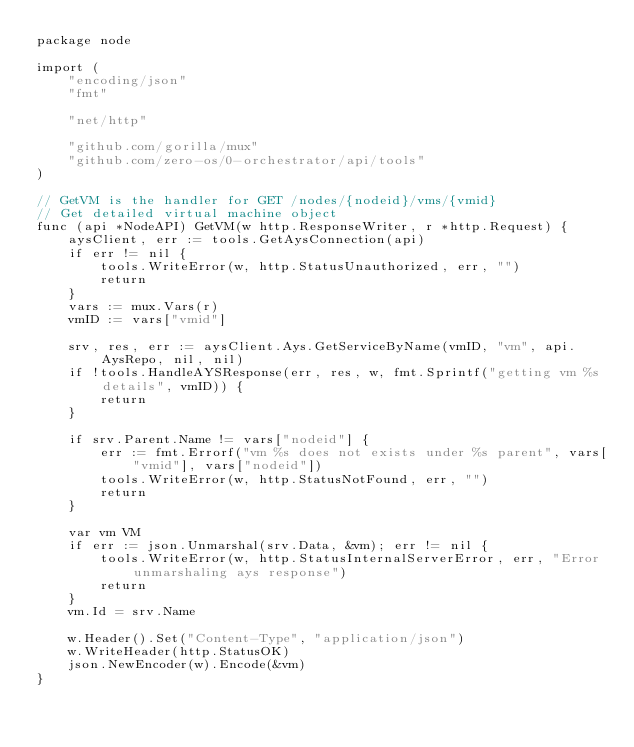Convert code to text. <code><loc_0><loc_0><loc_500><loc_500><_Go_>package node

import (
	"encoding/json"
	"fmt"

	"net/http"

	"github.com/gorilla/mux"
	"github.com/zero-os/0-orchestrator/api/tools"
)

// GetVM is the handler for GET /nodes/{nodeid}/vms/{vmid}
// Get detailed virtual machine object
func (api *NodeAPI) GetVM(w http.ResponseWriter, r *http.Request) {
	aysClient, err := tools.GetAysConnection(api)
	if err != nil {
		tools.WriteError(w, http.StatusUnauthorized, err, "")
		return
	}
	vars := mux.Vars(r)
	vmID := vars["vmid"]

	srv, res, err := aysClient.Ays.GetServiceByName(vmID, "vm", api.AysRepo, nil, nil)
	if !tools.HandleAYSResponse(err, res, w, fmt.Sprintf("getting vm %s details", vmID)) {
		return
	}

	if srv.Parent.Name != vars["nodeid"] {
		err := fmt.Errorf("vm %s does not exists under %s parent", vars["vmid"], vars["nodeid"])
		tools.WriteError(w, http.StatusNotFound, err, "")
		return
	}

	var vm VM
	if err := json.Unmarshal(srv.Data, &vm); err != nil {
		tools.WriteError(w, http.StatusInternalServerError, err, "Error unmarshaling ays response")
		return
	}
	vm.Id = srv.Name

	w.Header().Set("Content-Type", "application/json")
	w.WriteHeader(http.StatusOK)
	json.NewEncoder(w).Encode(&vm)
}
</code> 